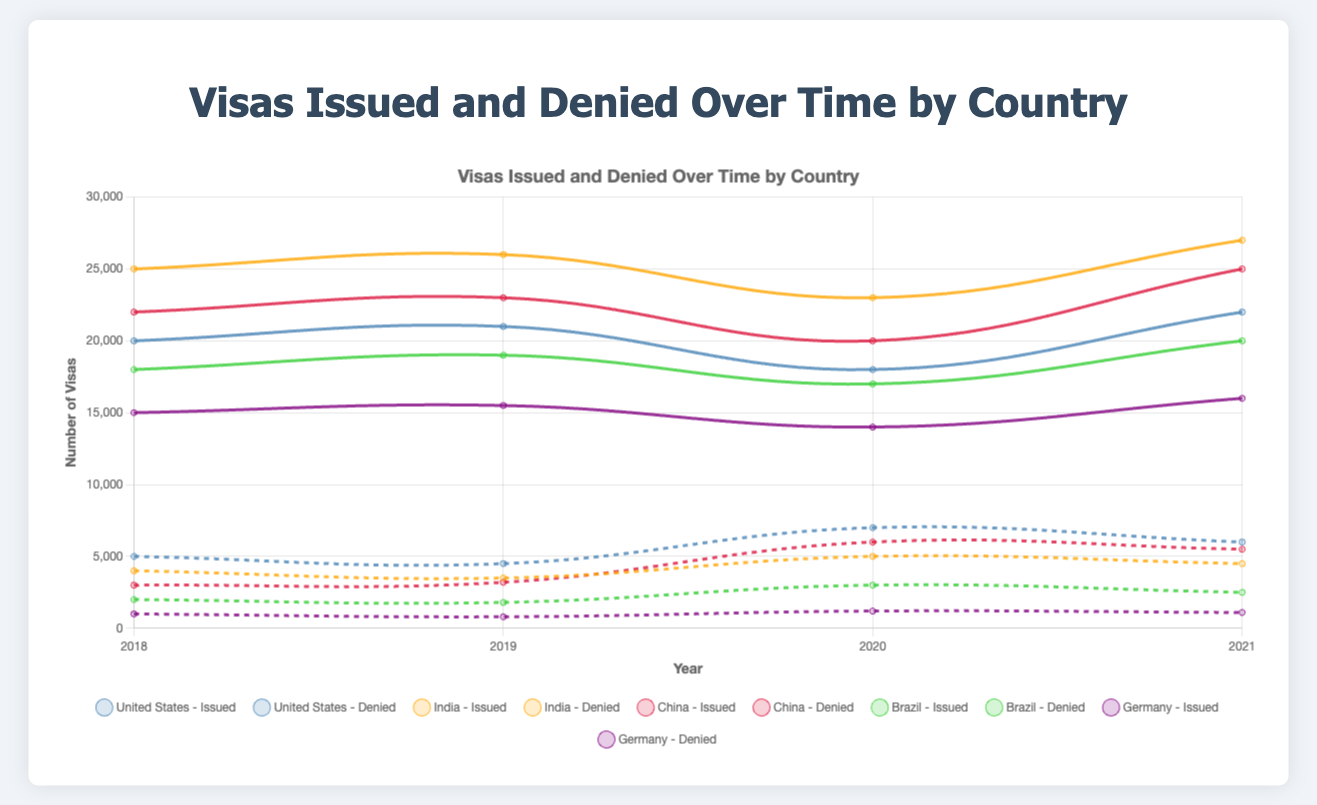What trend can be observed for visas issued and denied for the United States from 2018 to 2021? The chart shows that visas issued for the United States slightly increased from 20000 in 2018 to 21000 in 2019, dropped to 18000 in 2020, and then increased again to 22000 in 2021. Visas denied decreased from 5000 in 2018 to 4500 in 2019, then increased to 7000 in 2020, and slightly decreased to 6000 in 2021.
Answer: Issued: Increase, Decrease, Increase; Denied: Decrease, Increase, Decrease Which country had the highest number of visas issued in 2021? By examining the plot for the year 2021, India had the highest number of visas issued at 27000.
Answer: India For China, what was the difference between visas issued and denied in 2020? In 2020, China had 20000 visas issued and 6000 visas denied. The difference is 20000 - 6000.
Answer: 14000 Compare the trend of visas denied in Brazil and Germany from 2018 to 2021. Which country had a more substantial increase? For Brazil, visas denied increased from 2000 in 2018 to 2500 in 2021. For Germany, visas denied increased from 1000 in 2018 to 1100 in 2021. The increase is greater for Brazil (500) compared to Germany (100).
Answer: Brazil What is the average number of visas issued by India over the four years provided? Sum of visas issued for India over the four years is 25000 + 26000 + 23000 + 27000 = 101000. The average is 101000 / 4.
Answer: 25250 Which country had the most consistent number of visas denied from 2018 to 2021? By observing the data visually in the plot, Germany shows the most consistent number of visas denied, with minor variations (1000, 800, 1200, 1100).
Answer: Germany Visually, which country's visas issued line shows the steepest increase between any two consecutive years? Examining the slopes of the lines, India's visas issued from 2020 to 2021 show the steepest increase from 23000 to 27000.
Answer: India 